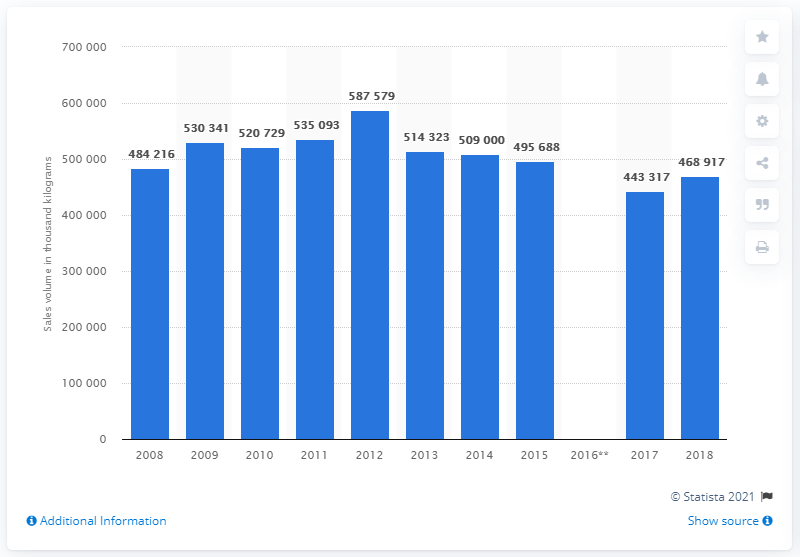Identify some key points in this picture. In 2018, the total sales volume of frozen potato products in the UK was 468,917 units. 